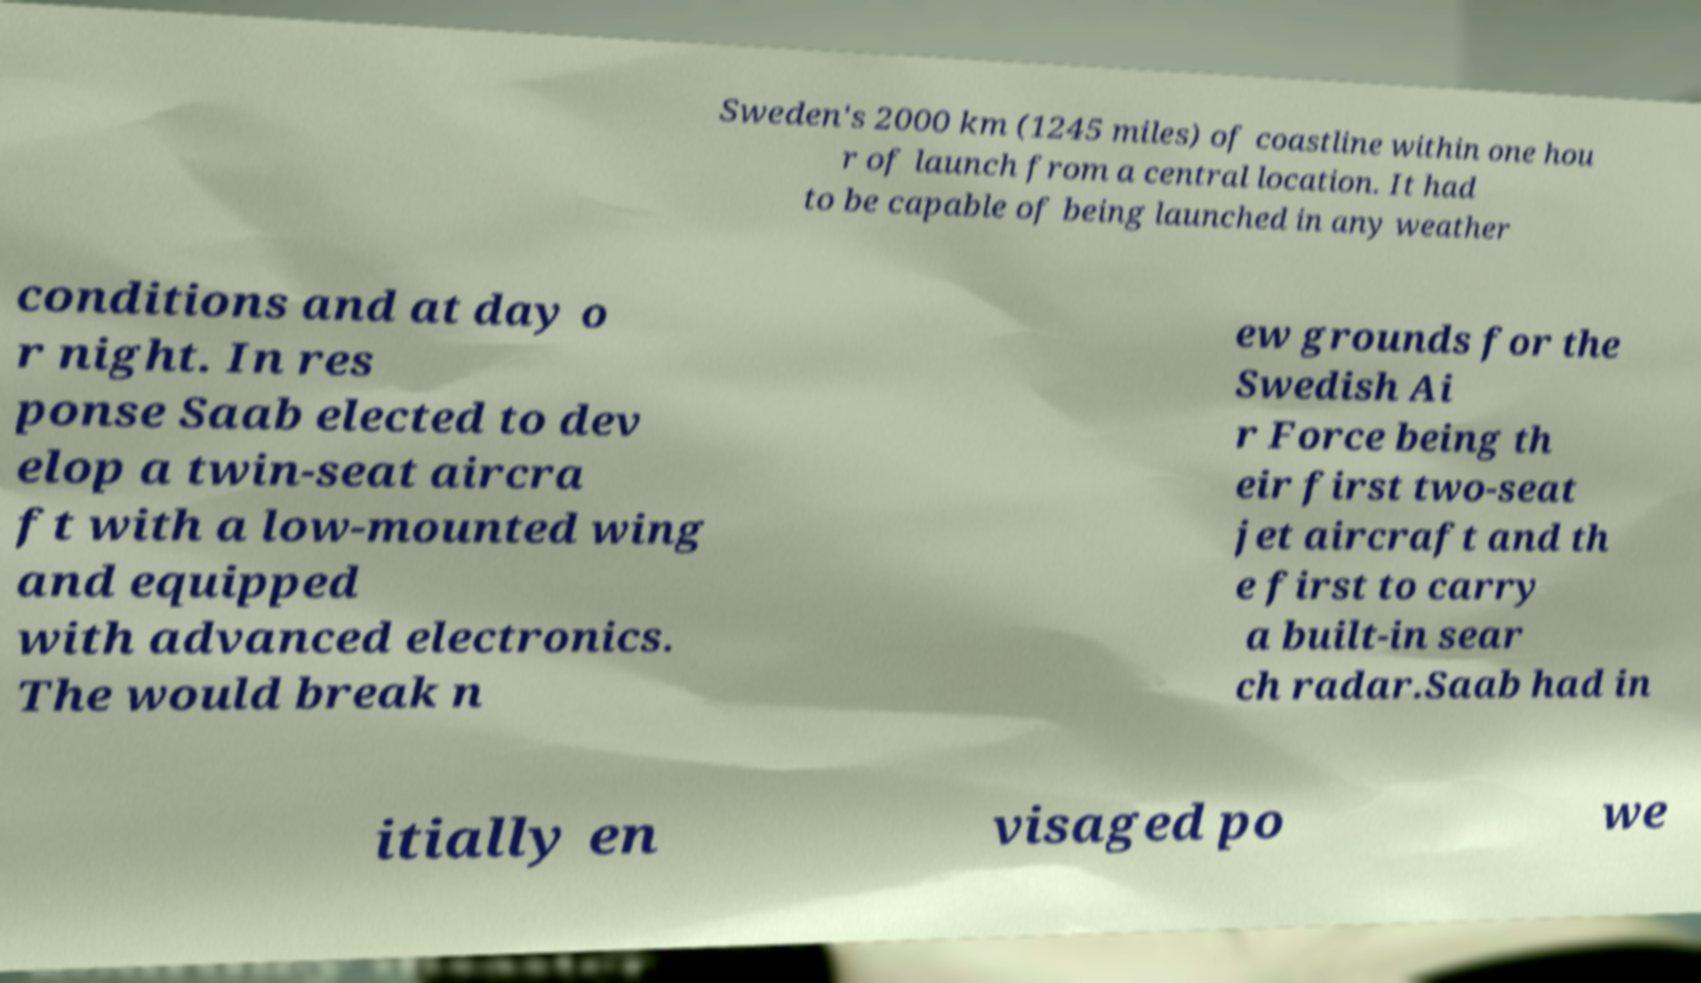Please identify and transcribe the text found in this image. Sweden's 2000 km (1245 miles) of coastline within one hou r of launch from a central location. It had to be capable of being launched in any weather conditions and at day o r night. In res ponse Saab elected to dev elop a twin-seat aircra ft with a low-mounted wing and equipped with advanced electronics. The would break n ew grounds for the Swedish Ai r Force being th eir first two-seat jet aircraft and th e first to carry a built-in sear ch radar.Saab had in itially en visaged po we 